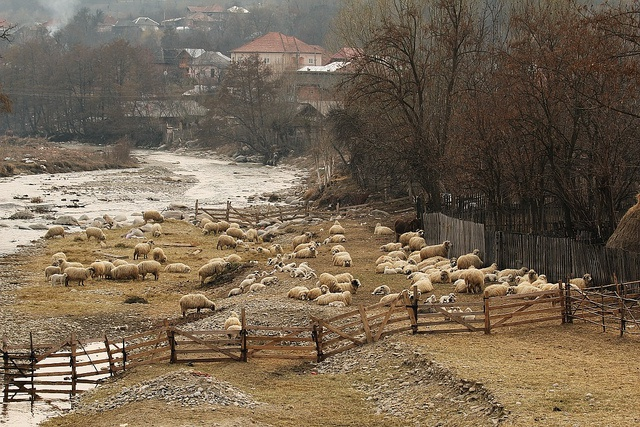Describe the objects in this image and their specific colors. I can see sheep in darkgray, tan, gray, maroon, and black tones, sheep in darkgray, maroon, gray, black, and tan tones, sheep in darkgray, maroon, black, and tan tones, sheep in darkgray, brown, black, gray, and tan tones, and sheep in darkgray, tan, gray, and maroon tones in this image. 